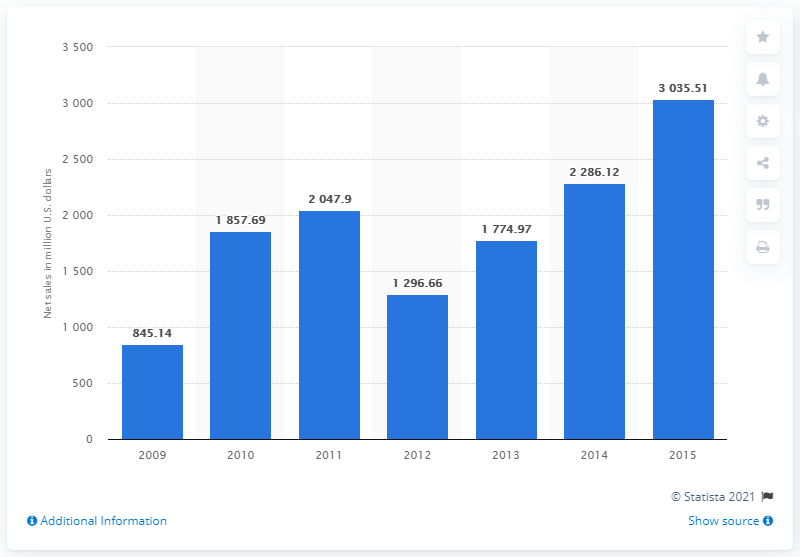Highlight a few significant elements in this photo. In FY 2012, Trina Solar's net sales were 1,296.66 million U.S. dollars. Trina Solar's last fiscal year was in 2009. 